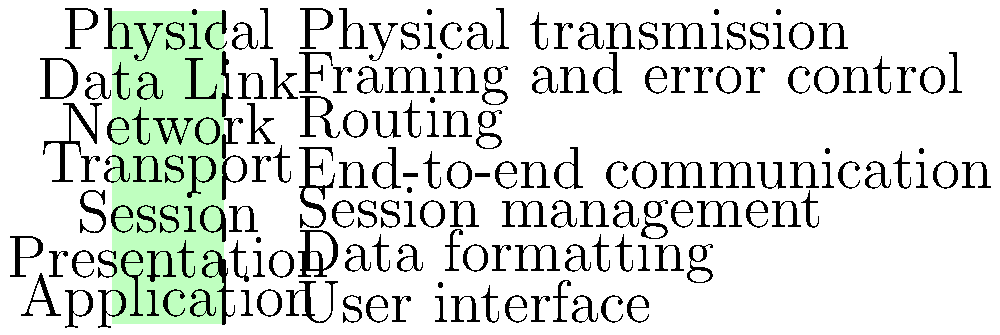As a multimedia journalist covering technology trends in Bihar, you're writing an article about digital communication. Which layer of the OSI model is responsible for routing data packets between different networks? To answer this question, let's break down the OSI (Open Systems Interconnection) model layers and their functions:

1. Physical Layer: Deals with the physical transmission of data over the network medium.
2. Data Link Layer: Handles framing of data and error control between directly connected nodes.
3. Network Layer: Responsible for routing data packets between different networks.
4. Transport Layer: Ensures end-to-end communication and reliability.
5. Session Layer: Manages and maintains sessions between applications.
6. Presentation Layer: Handles data formatting, encryption, and compression.
7. Application Layer: Provides the user interface and network services to applications.

The key function we're looking for is "routing data packets between different networks." This is explicitly the responsibility of the Network Layer (layer 3) in the OSI model. The Network Layer determines the best path for data to travel from the source to the destination, even if they are on different networks.

As a multimedia journalist, understanding this concept is crucial when reporting on digital communication technologies and explaining how data travels across the internet to your readers in Bihar.
Answer: Network Layer 